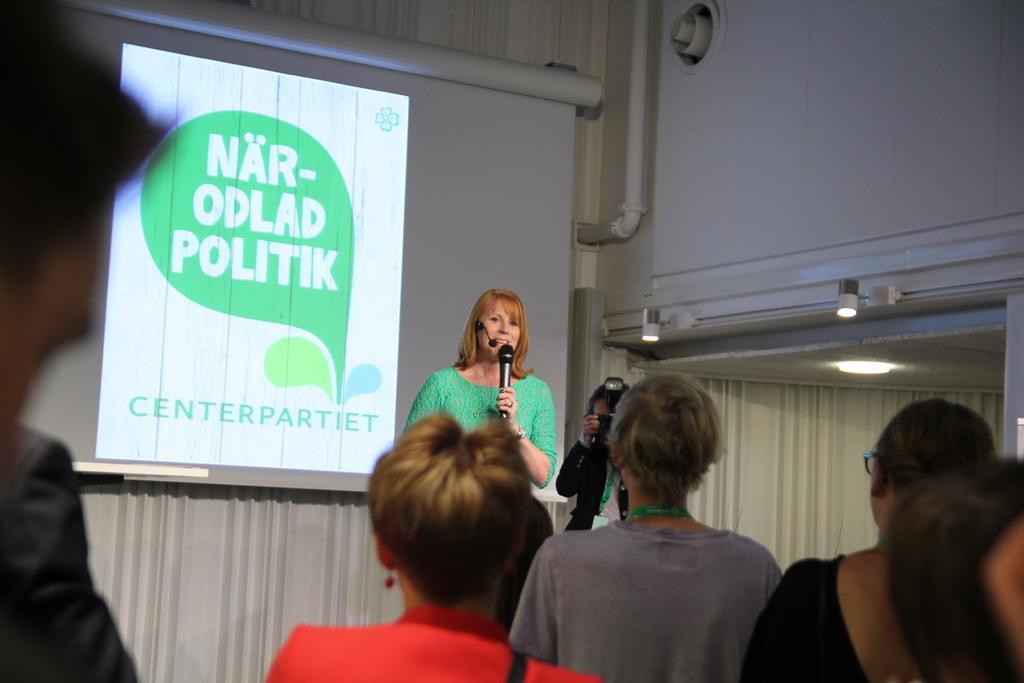In one or two sentences, can you explain what this image depicts? In this picture there is a person in green top[ holding a mic and standing on the stage behind there is a screen and a lady who is holding the camera and in front of them there are some people standing. 